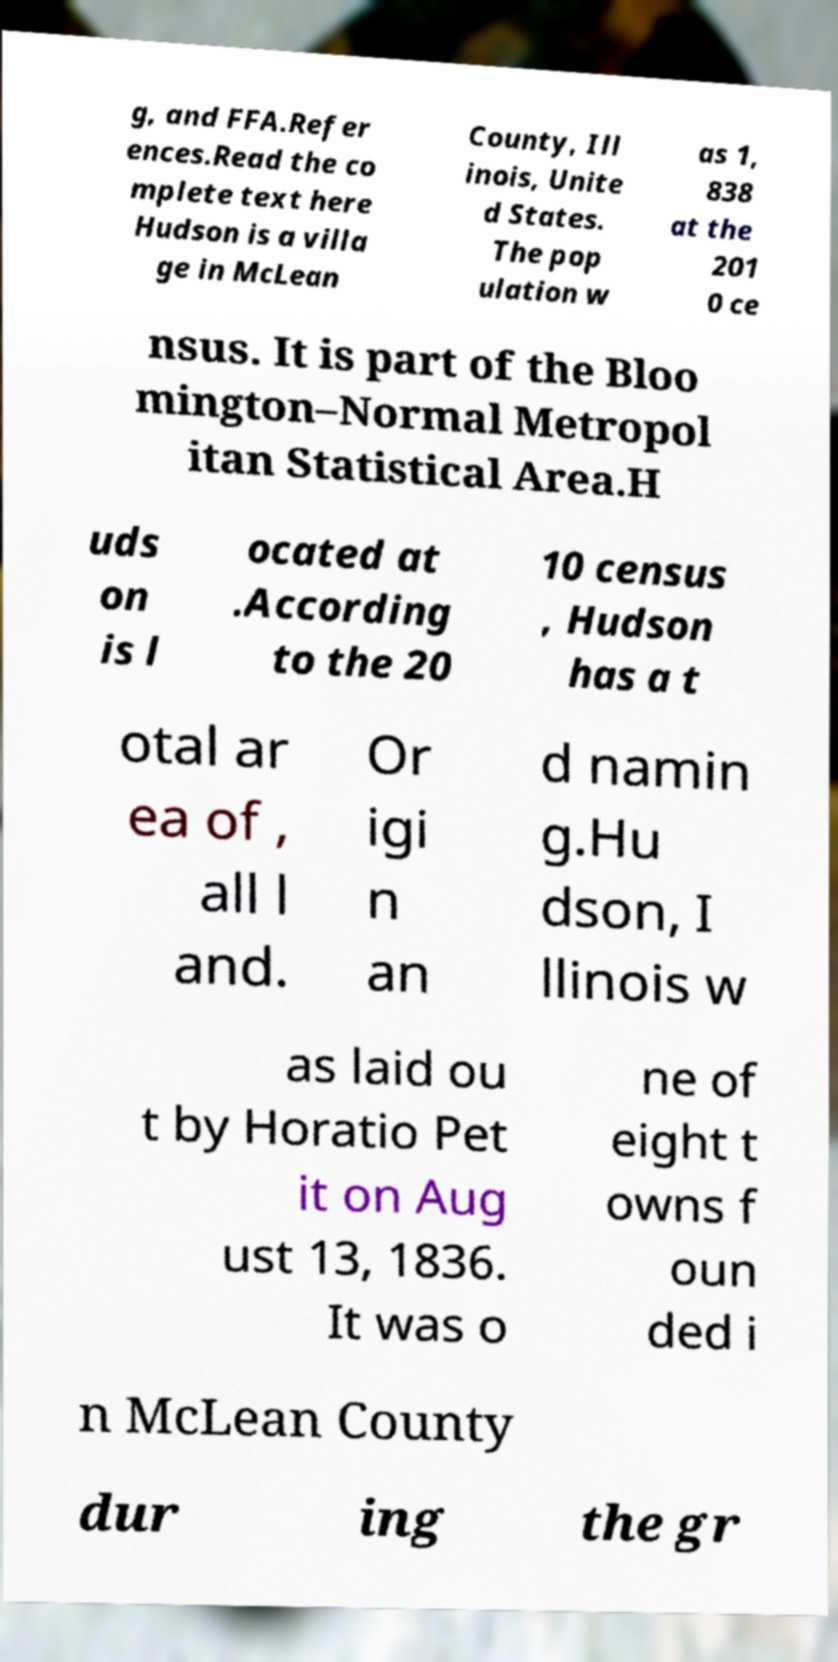Can you read and provide the text displayed in the image?This photo seems to have some interesting text. Can you extract and type it out for me? g, and FFA.Refer ences.Read the co mplete text here Hudson is a villa ge in McLean County, Ill inois, Unite d States. The pop ulation w as 1, 838 at the 201 0 ce nsus. It is part of the Bloo mington–Normal Metropol itan Statistical Area.H uds on is l ocated at .According to the 20 10 census , Hudson has a t otal ar ea of , all l and. Or igi n an d namin g.Hu dson, I llinois w as laid ou t by Horatio Pet it on Aug ust 13, 1836. It was o ne of eight t owns f oun ded i n McLean County dur ing the gr 